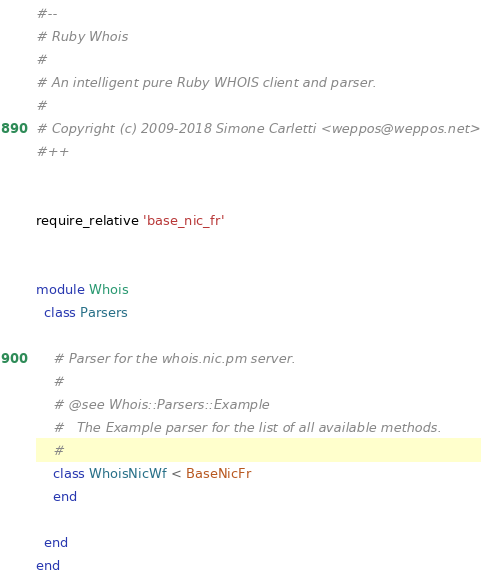Convert code to text. <code><loc_0><loc_0><loc_500><loc_500><_Ruby_>#--
# Ruby Whois
#
# An intelligent pure Ruby WHOIS client and parser.
#
# Copyright (c) 2009-2018 Simone Carletti <weppos@weppos.net>
#++


require_relative 'base_nic_fr'


module Whois
  class Parsers

    # Parser for the whois.nic.pm server.
    #
    # @see Whois::Parsers::Example
    #   The Example parser for the list of all available methods.
    #
    class WhoisNicWf < BaseNicFr
    end

  end
end
</code> 